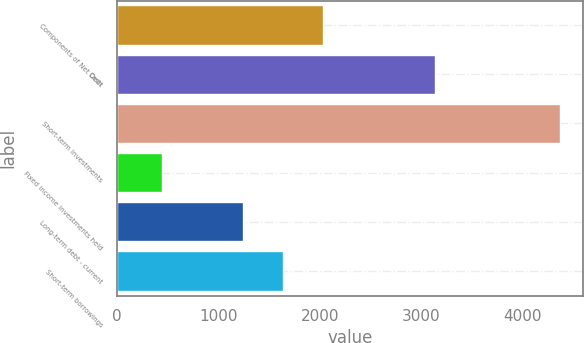Convert chart. <chart><loc_0><loc_0><loc_500><loc_500><bar_chart><fcel>Components of Net Debt<fcel>Cash<fcel>Short-term investments<fcel>Fixed income investments held<fcel>Long-term debt - current<fcel>Short-term borrowings<nl><fcel>2029.8<fcel>3130<fcel>4371<fcel>442<fcel>1244<fcel>1636.9<nl></chart> 